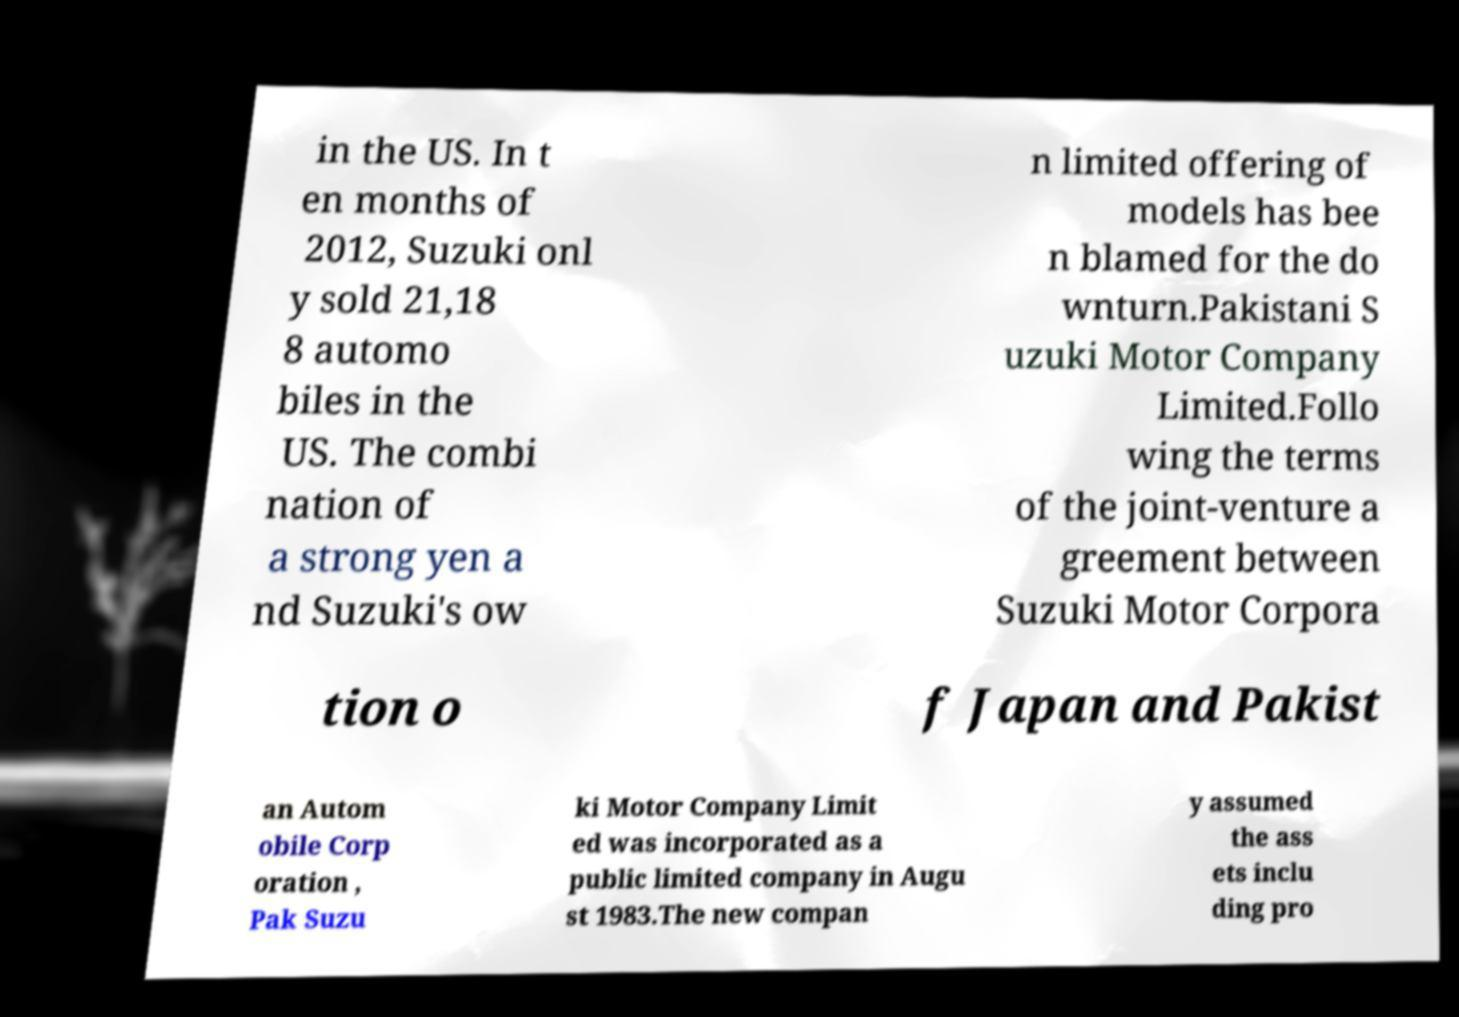Could you assist in decoding the text presented in this image and type it out clearly? in the US. In t en months of 2012, Suzuki onl y sold 21,18 8 automo biles in the US. The combi nation of a strong yen a nd Suzuki's ow n limited offering of models has bee n blamed for the do wnturn.Pakistani S uzuki Motor Company Limited.Follo wing the terms of the joint-venture a greement between Suzuki Motor Corpora tion o f Japan and Pakist an Autom obile Corp oration , Pak Suzu ki Motor Company Limit ed was incorporated as a public limited company in Augu st 1983.The new compan y assumed the ass ets inclu ding pro 